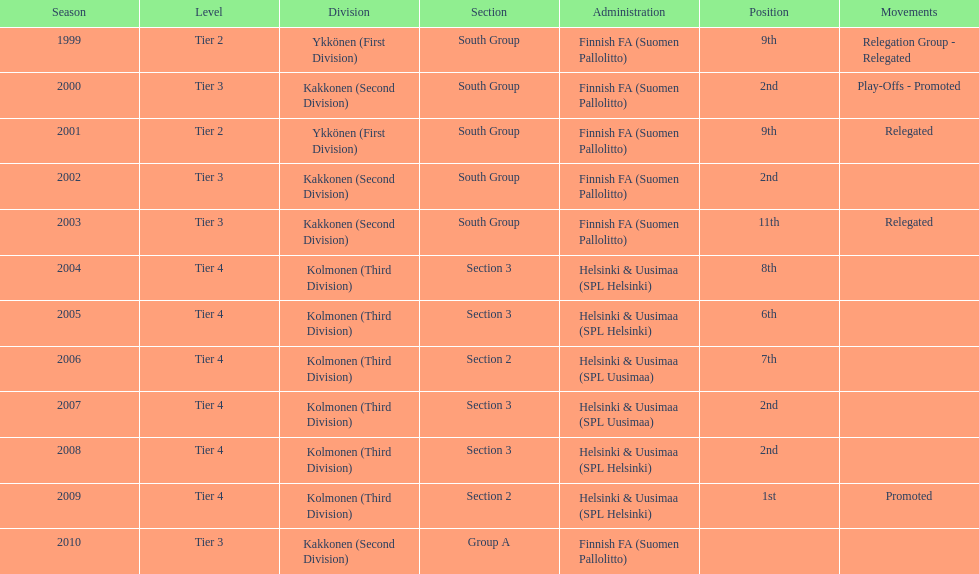How many second places were there? 4. 